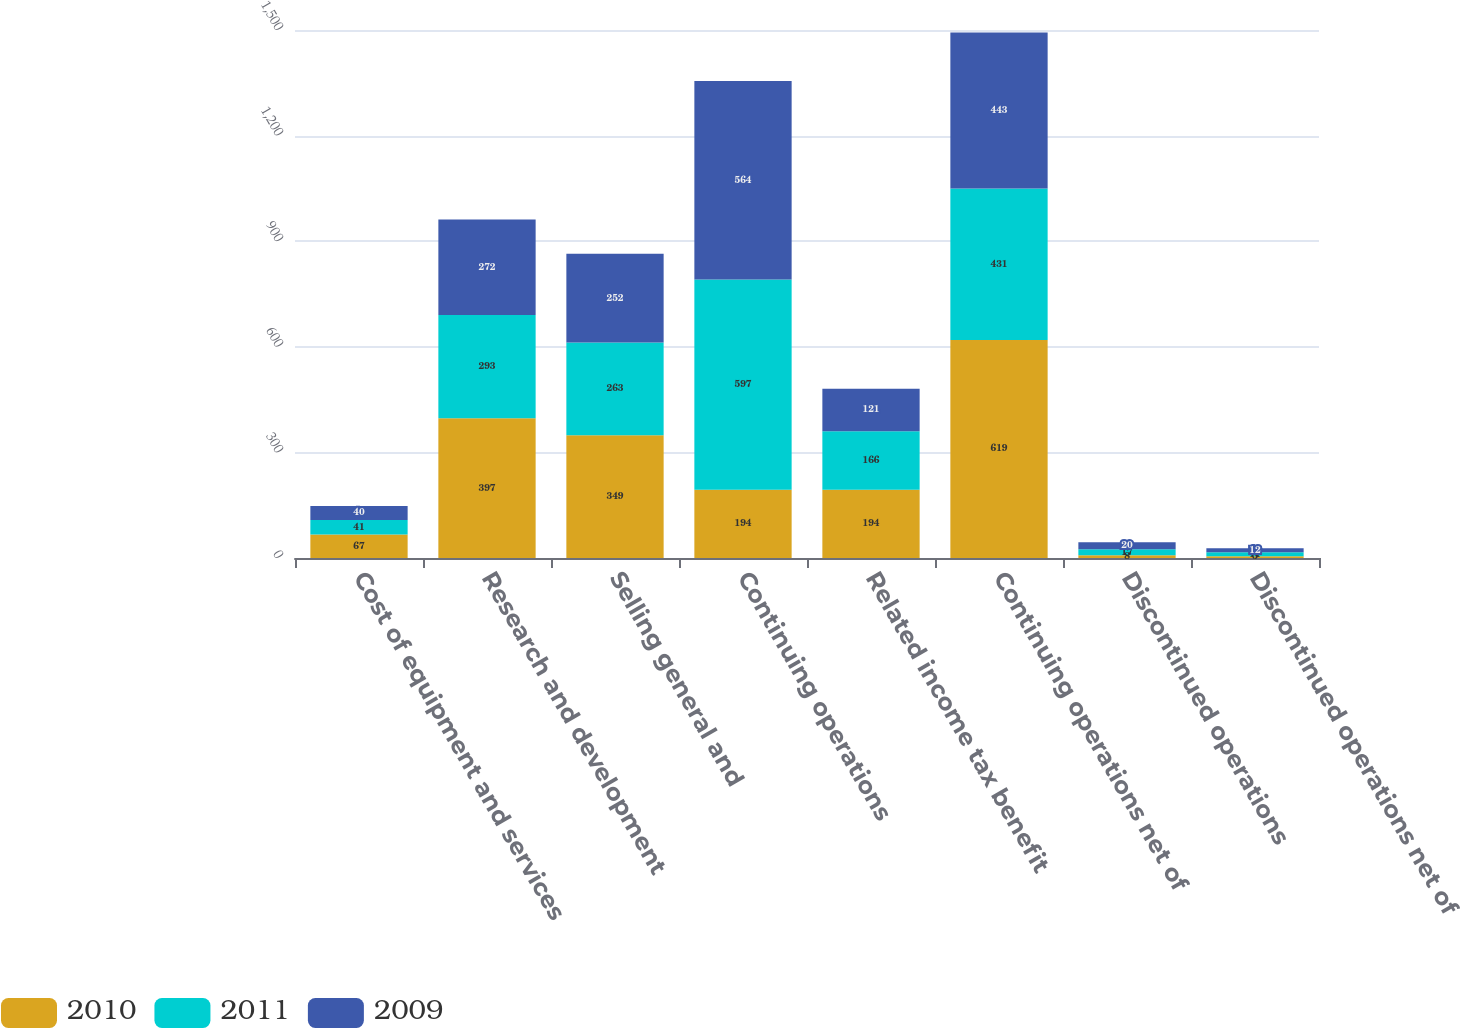Convert chart to OTSL. <chart><loc_0><loc_0><loc_500><loc_500><stacked_bar_chart><ecel><fcel>Cost of equipment and services<fcel>Research and development<fcel>Selling general and<fcel>Continuing operations<fcel>Related income tax benefit<fcel>Continuing operations net of<fcel>Discontinued operations<fcel>Discontinued operations net of<nl><fcel>2010<fcel>67<fcel>397<fcel>349<fcel>194<fcel>194<fcel>619<fcel>8<fcel>5<nl><fcel>2011<fcel>41<fcel>293<fcel>263<fcel>597<fcel>166<fcel>431<fcel>17<fcel>11<nl><fcel>2009<fcel>40<fcel>272<fcel>252<fcel>564<fcel>121<fcel>443<fcel>20<fcel>12<nl></chart> 